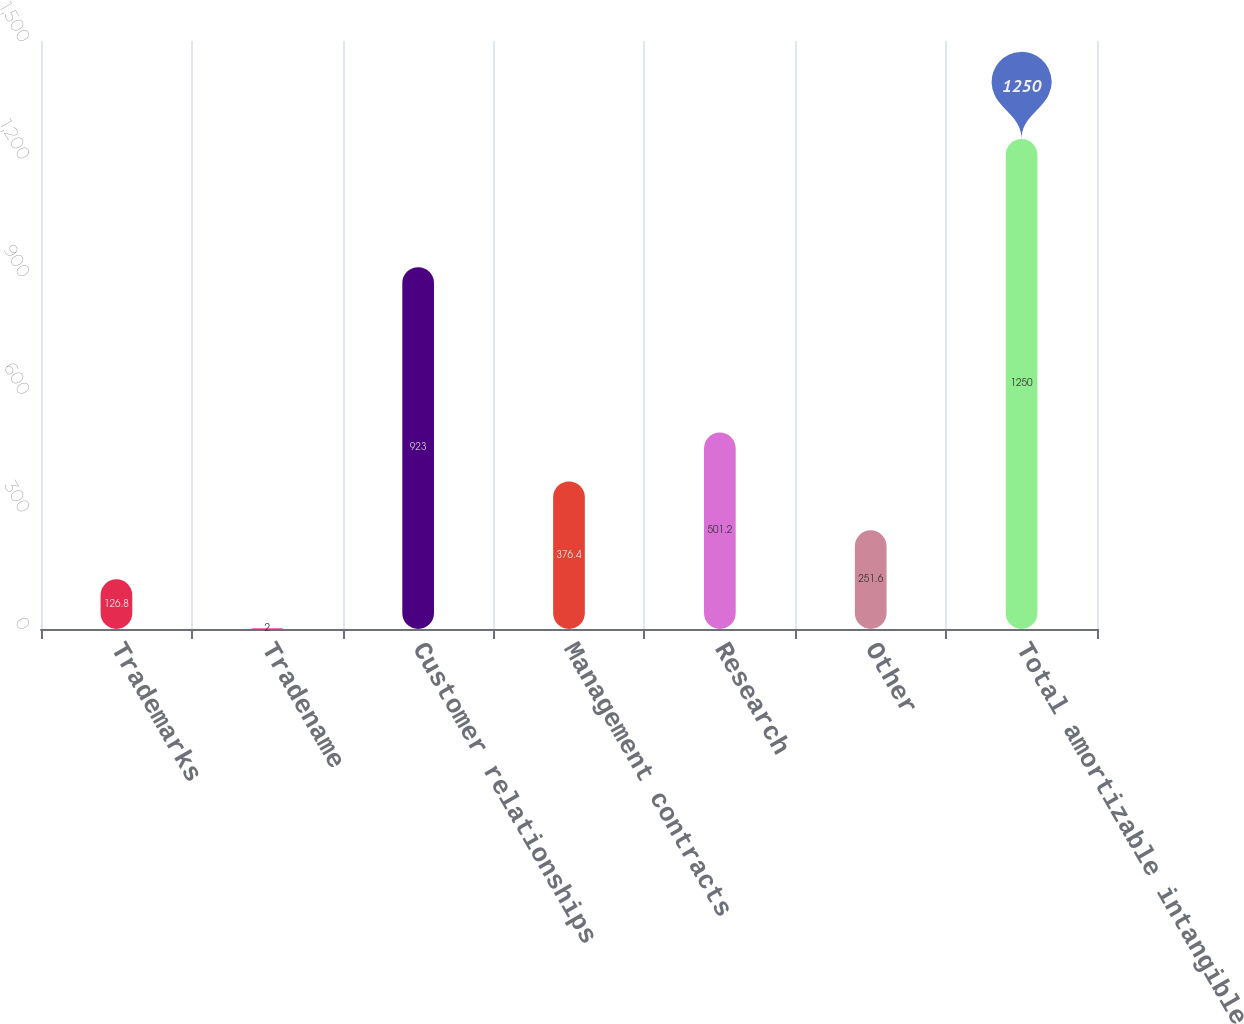<chart> <loc_0><loc_0><loc_500><loc_500><bar_chart><fcel>Trademarks<fcel>Tradename<fcel>Customer relationships<fcel>Management contracts<fcel>Research<fcel>Other<fcel>Total amortizable intangible<nl><fcel>126.8<fcel>2<fcel>923<fcel>376.4<fcel>501.2<fcel>251.6<fcel>1250<nl></chart> 